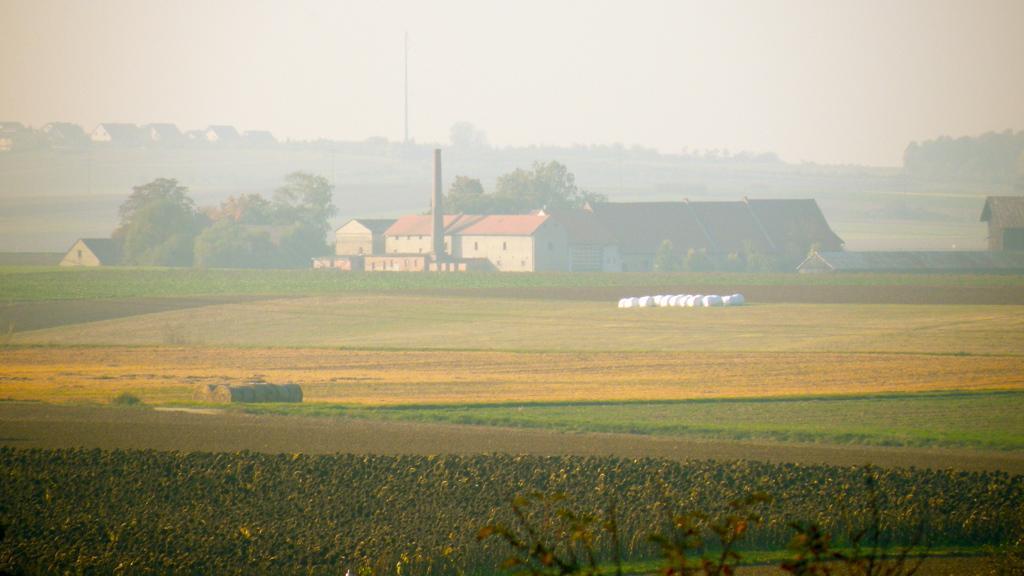How would you summarize this image in a sentence or two? Front side of the image we can see plants and grass. Background we can see houses,trees and sky. 